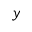<formula> <loc_0><loc_0><loc_500><loc_500>y</formula> 